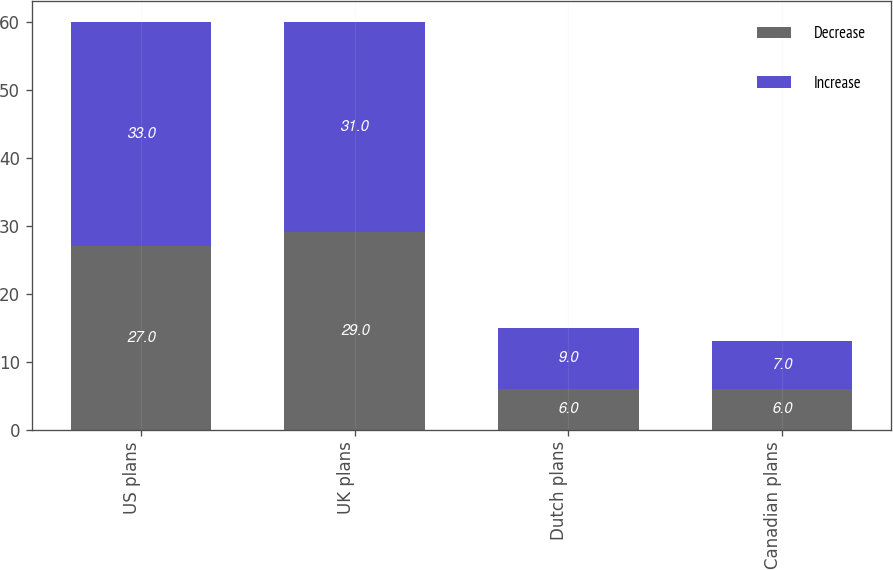Convert chart. <chart><loc_0><loc_0><loc_500><loc_500><stacked_bar_chart><ecel><fcel>US plans<fcel>UK plans<fcel>Dutch plans<fcel>Canadian plans<nl><fcel>Decrease<fcel>27<fcel>29<fcel>6<fcel>6<nl><fcel>Increase<fcel>33<fcel>31<fcel>9<fcel>7<nl></chart> 